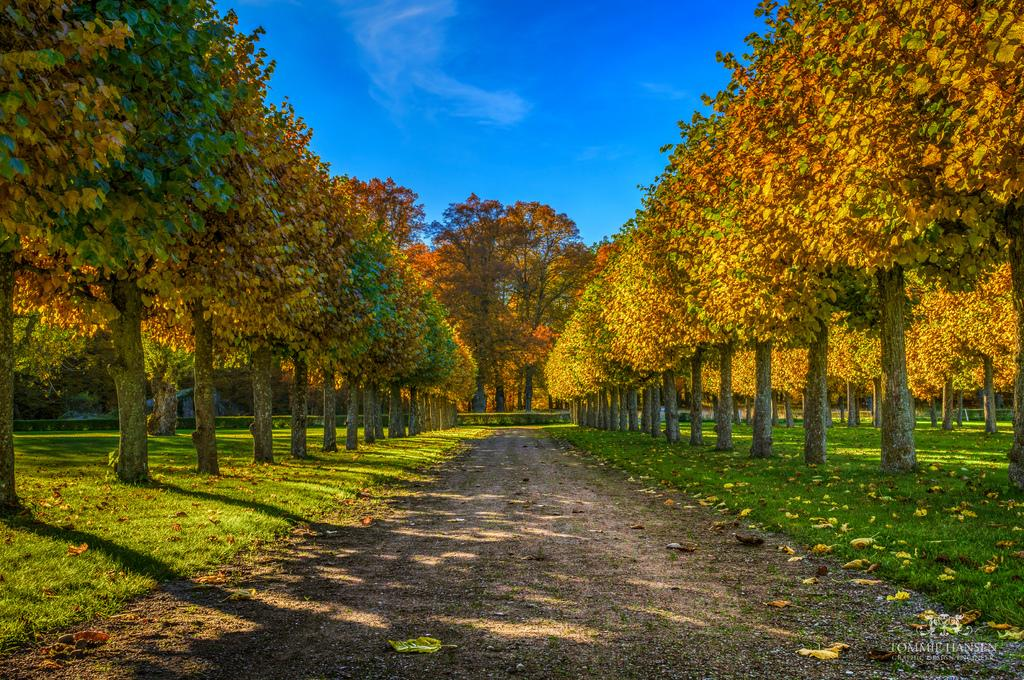What type of vegetation is present in the image? There are trees on a grassy land in the image. What is the color of the sky in the background of the image? The sky is blue in the background of the image. What is the opinion of the dog about the trees in the image? There is no dog present in the image, so it is not possible to determine its opinion about the trees. 